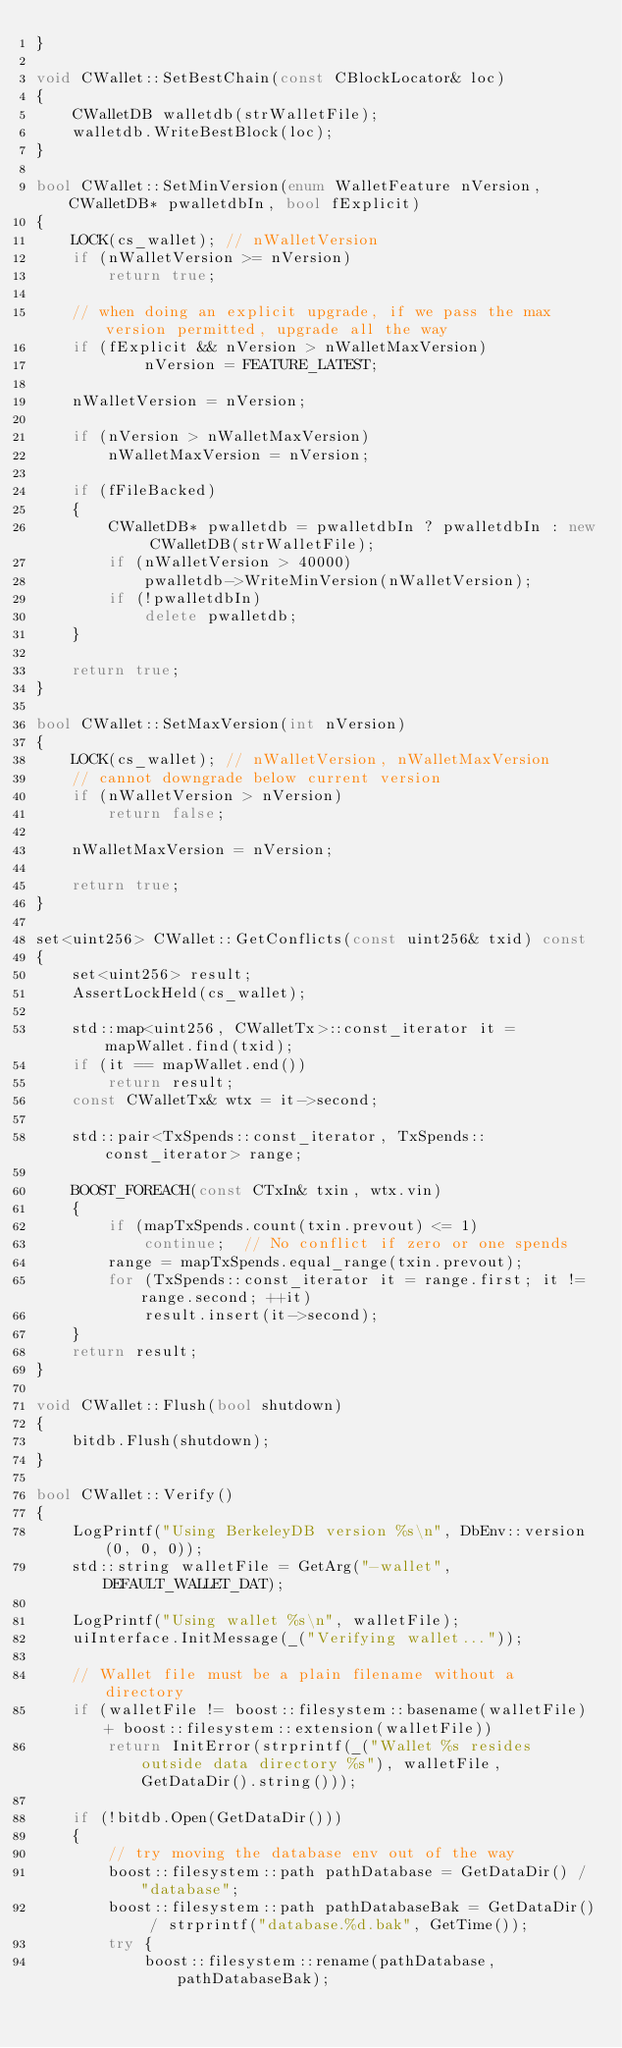<code> <loc_0><loc_0><loc_500><loc_500><_C++_>}

void CWallet::SetBestChain(const CBlockLocator& loc)
{
    CWalletDB walletdb(strWalletFile);
    walletdb.WriteBestBlock(loc);
}

bool CWallet::SetMinVersion(enum WalletFeature nVersion, CWalletDB* pwalletdbIn, bool fExplicit)
{
    LOCK(cs_wallet); // nWalletVersion
    if (nWalletVersion >= nVersion)
        return true;

    // when doing an explicit upgrade, if we pass the max version permitted, upgrade all the way
    if (fExplicit && nVersion > nWalletMaxVersion)
            nVersion = FEATURE_LATEST;

    nWalletVersion = nVersion;

    if (nVersion > nWalletMaxVersion)
        nWalletMaxVersion = nVersion;

    if (fFileBacked)
    {
        CWalletDB* pwalletdb = pwalletdbIn ? pwalletdbIn : new CWalletDB(strWalletFile);
        if (nWalletVersion > 40000)
            pwalletdb->WriteMinVersion(nWalletVersion);
        if (!pwalletdbIn)
            delete pwalletdb;
    }

    return true;
}

bool CWallet::SetMaxVersion(int nVersion)
{
    LOCK(cs_wallet); // nWalletVersion, nWalletMaxVersion
    // cannot downgrade below current version
    if (nWalletVersion > nVersion)
        return false;

    nWalletMaxVersion = nVersion;

    return true;
}

set<uint256> CWallet::GetConflicts(const uint256& txid) const
{
    set<uint256> result;
    AssertLockHeld(cs_wallet);

    std::map<uint256, CWalletTx>::const_iterator it = mapWallet.find(txid);
    if (it == mapWallet.end())
        return result;
    const CWalletTx& wtx = it->second;

    std::pair<TxSpends::const_iterator, TxSpends::const_iterator> range;

    BOOST_FOREACH(const CTxIn& txin, wtx.vin)
    {
        if (mapTxSpends.count(txin.prevout) <= 1)
            continue;  // No conflict if zero or one spends
        range = mapTxSpends.equal_range(txin.prevout);
        for (TxSpends::const_iterator it = range.first; it != range.second; ++it)
            result.insert(it->second);
    }
    return result;
}

void CWallet::Flush(bool shutdown)
{
    bitdb.Flush(shutdown);
}

bool CWallet::Verify()
{
    LogPrintf("Using BerkeleyDB version %s\n", DbEnv::version(0, 0, 0));
    std::string walletFile = GetArg("-wallet", DEFAULT_WALLET_DAT);

    LogPrintf("Using wallet %s\n", walletFile);
    uiInterface.InitMessage(_("Verifying wallet..."));

    // Wallet file must be a plain filename without a directory
    if (walletFile != boost::filesystem::basename(walletFile) + boost::filesystem::extension(walletFile))
        return InitError(strprintf(_("Wallet %s resides outside data directory %s"), walletFile, GetDataDir().string()));

    if (!bitdb.Open(GetDataDir()))
    {
        // try moving the database env out of the way
        boost::filesystem::path pathDatabase = GetDataDir() / "database";
        boost::filesystem::path pathDatabaseBak = GetDataDir() / strprintf("database.%d.bak", GetTime());
        try {
            boost::filesystem::rename(pathDatabase, pathDatabaseBak);</code> 